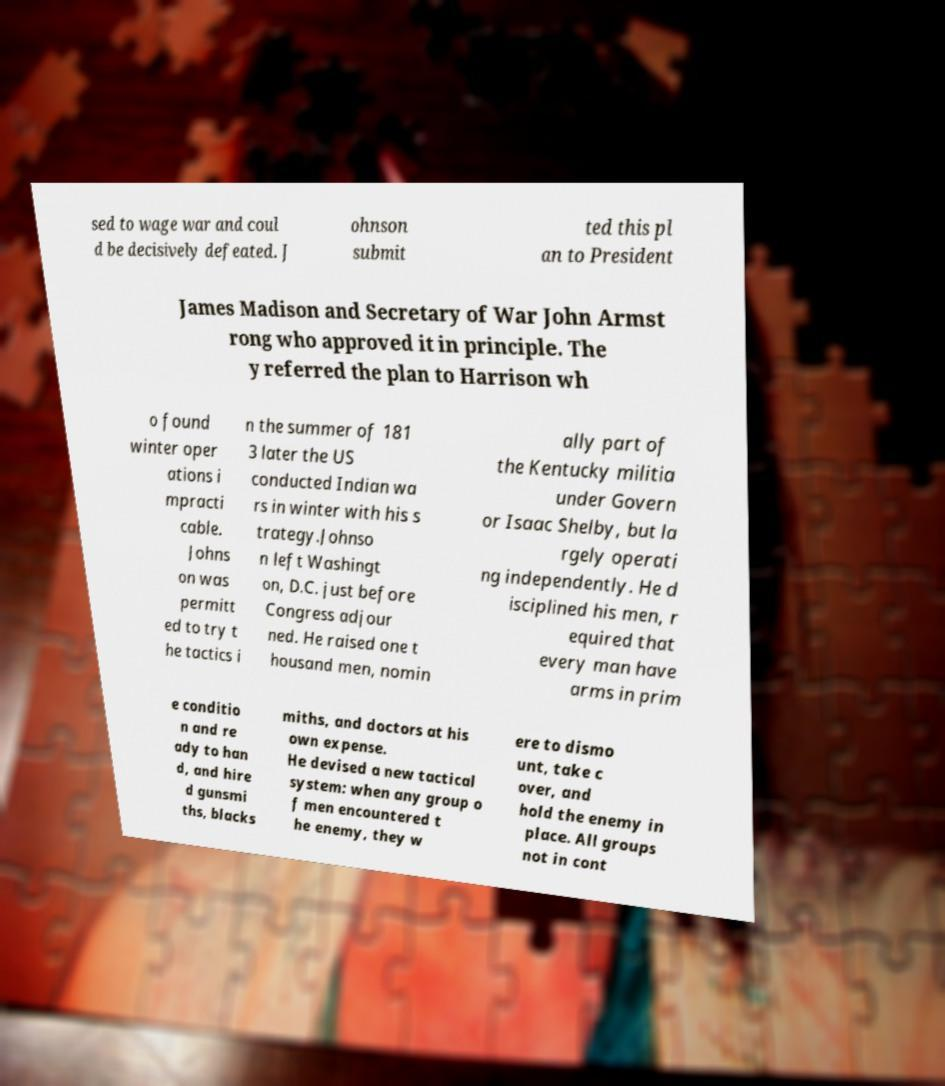Please identify and transcribe the text found in this image. sed to wage war and coul d be decisively defeated. J ohnson submit ted this pl an to President James Madison and Secretary of War John Armst rong who approved it in principle. The y referred the plan to Harrison wh o found winter oper ations i mpracti cable. Johns on was permitt ed to try t he tactics i n the summer of 181 3 later the US conducted Indian wa rs in winter with his s trategy.Johnso n left Washingt on, D.C. just before Congress adjour ned. He raised one t housand men, nomin ally part of the Kentucky militia under Govern or Isaac Shelby, but la rgely operati ng independently. He d isciplined his men, r equired that every man have arms in prim e conditio n and re ady to han d, and hire d gunsmi ths, blacks miths, and doctors at his own expense. He devised a new tactical system: when any group o f men encountered t he enemy, they w ere to dismo unt, take c over, and hold the enemy in place. All groups not in cont 